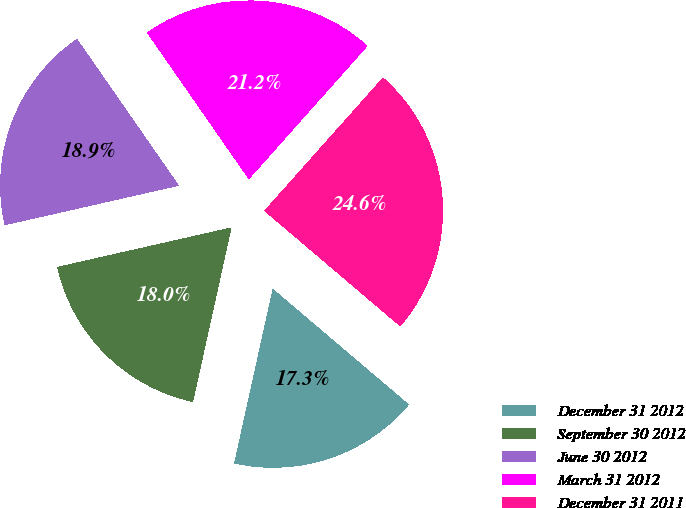<chart> <loc_0><loc_0><loc_500><loc_500><pie_chart><fcel>December 31 2012<fcel>September 30 2012<fcel>June 30 2012<fcel>March 31 2012<fcel>December 31 2011<nl><fcel>17.25%<fcel>17.99%<fcel>18.89%<fcel>21.24%<fcel>24.63%<nl></chart> 